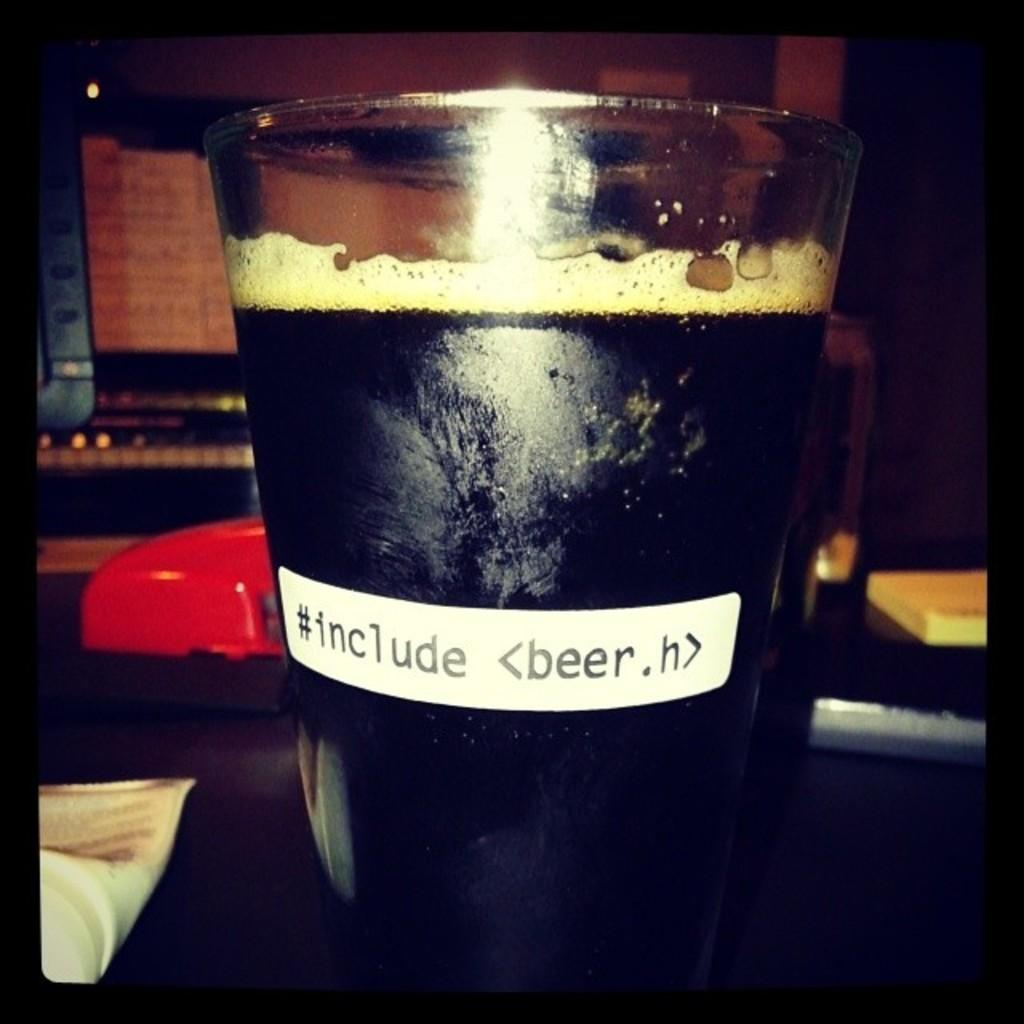<image>
Present a compact description of the photo's key features. Someone put a label on a glass of beer that says #include. 